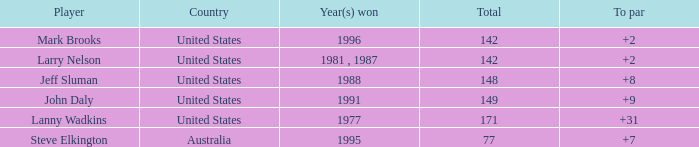Name the Total of jeff sluman? 148.0. 